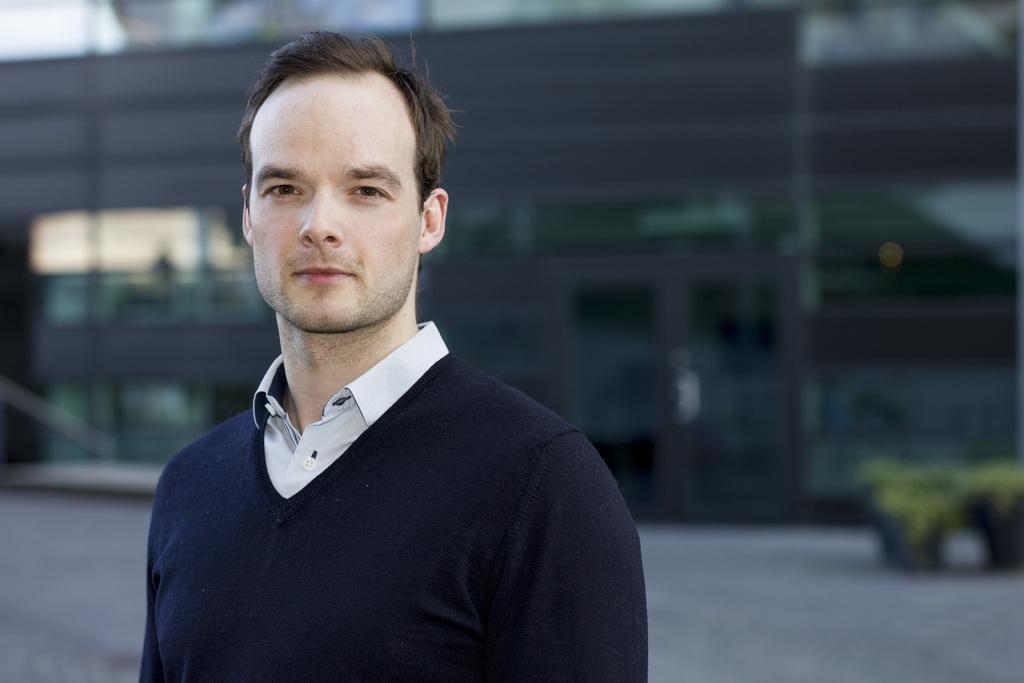In one or two sentences, can you explain what this image depicts? In this image we can see this person wearing dark blue color T-shirt and shirt is standing and smiling. The background of the image is slightly blurred, where we can see a building and plants here. 